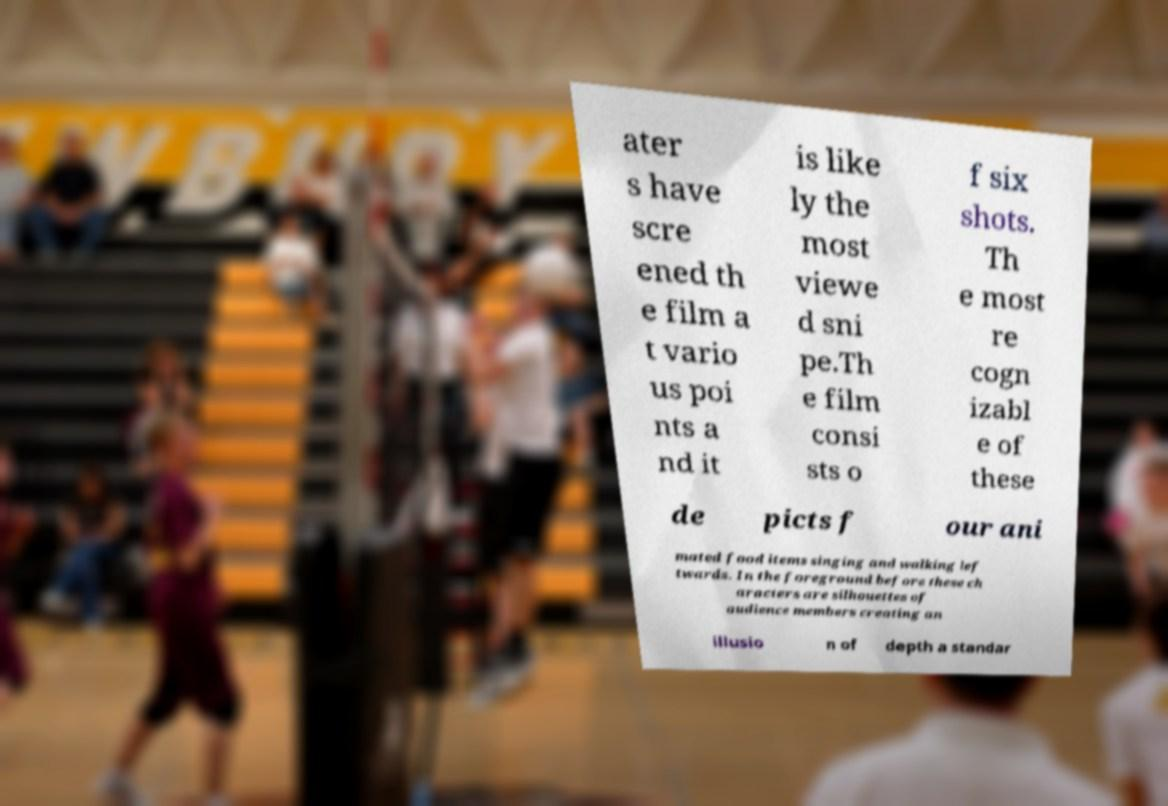For documentation purposes, I need the text within this image transcribed. Could you provide that? ater s have scre ened th e film a t vario us poi nts a nd it is like ly the most viewe d sni pe.Th e film consi sts o f six shots. Th e most re cogn izabl e of these de picts f our ani mated food items singing and walking lef twards. In the foreground before these ch aracters are silhouettes of audience members creating an illusio n of depth a standar 